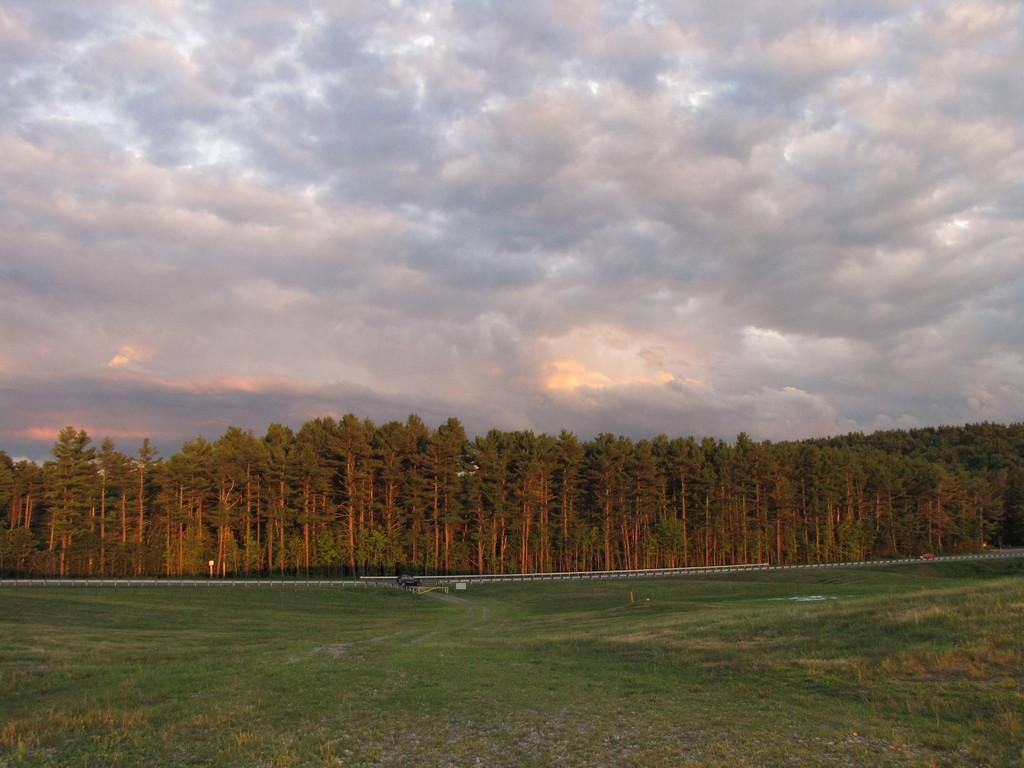What type of ground surface is visible in the image? There is grass on the ground in the image. What can be seen in the distance in the image? There are trees in the background of the image. What is visible at the top of the image? The sky is visible at the top of the image. What can be observed in the sky? There are clouds in the sky. Where is the crate being led by the army in the image? There is no crate or army present in the image. 